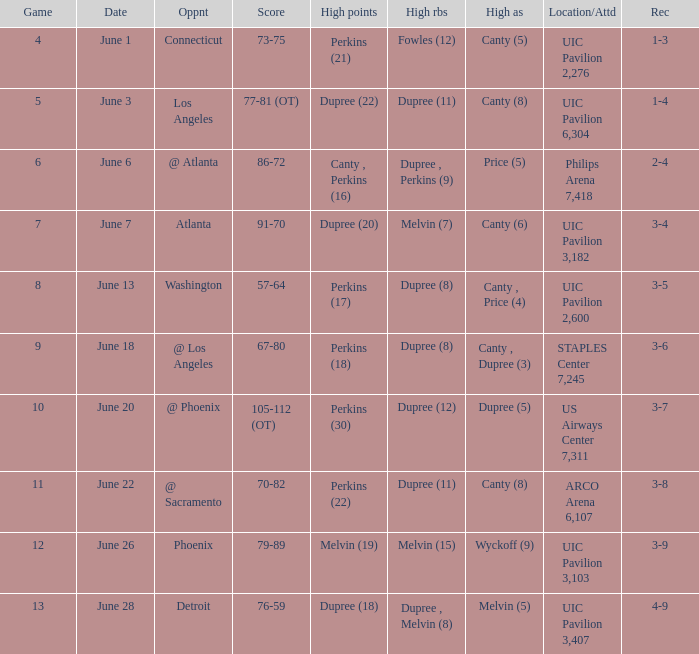Who had the most assists in the game that led to a 3-7 record? Dupree (5). 